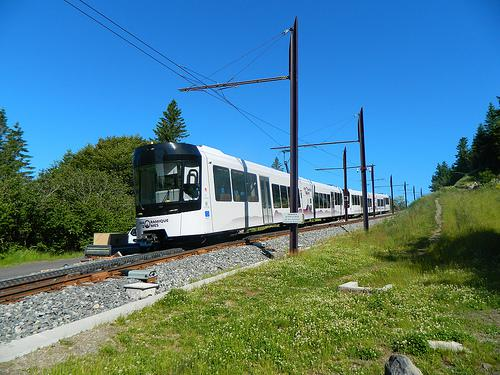Question: what is the train ridding on?
Choices:
A. It isn't riding.
B. On monorail.
C. On train tracks.
D. On electric rail.
Answer with the letter. Answer: C Question: how are trains powered?
Choices:
A. An engine.
B. Wind.
C. Solar engine.
D. Coal.
Answer with the letter. Answer: A Question: what color is the train?
Choices:
A. Silver.
B. Red.
C. Blue.
D. Black and white.
Answer with the letter. Answer: D Question: who drives a train?
Choices:
A. Pilot.
B. Soldier.
C. A train engineer.
D. Bus driver.
Answer with the letter. Answer: C Question: who else works on a train?
Choices:
A. Dancer.
B. A conductor.
C. Teacher.
D. Athlete.
Answer with the letter. Answer: B Question: what are train tracks made of?
Choices:
A. Steel.
B. Rubber.
C. Wood.
D. Aluminum.
Answer with the letter. Answer: A 